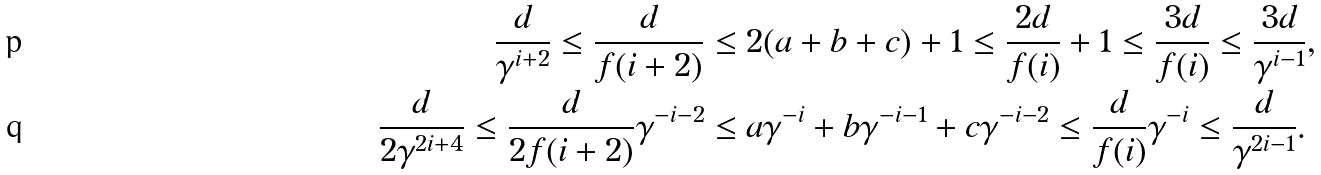Convert formula to latex. <formula><loc_0><loc_0><loc_500><loc_500>\frac { d } { \gamma ^ { i + 2 } } \leq \frac { d } { f ( i + 2 ) } & \leq 2 ( a + b + c ) + 1 \leq \frac { 2 d } { f ( i ) } + 1 \leq \frac { 3 d } { f ( i ) } \leq \frac { 3 d } { \gamma ^ { i - 1 } } , \\ \frac { d } { 2 \gamma ^ { 2 i + 4 } } \leq \frac { d } { 2 f ( i + 2 ) } \gamma ^ { - i - 2 } & \leq a \gamma ^ { - i } + b \gamma ^ { - i - 1 } + c \gamma ^ { - i - 2 } \leq \frac { d } { f ( i ) } \gamma ^ { - i } \leq \frac { d } { \gamma ^ { 2 i - 1 } } .</formula> 